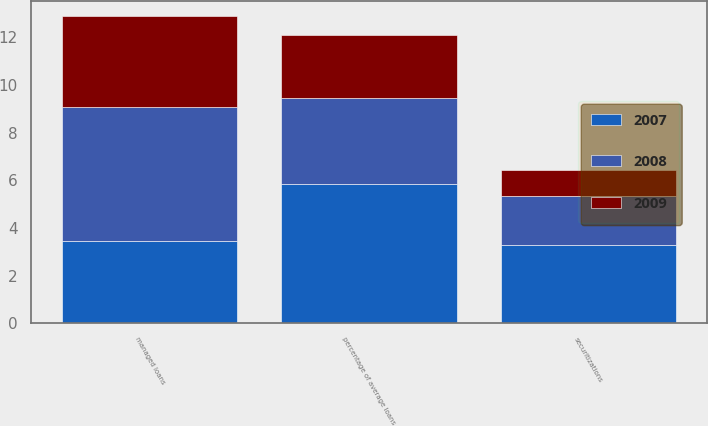<chart> <loc_0><loc_0><loc_500><loc_500><stacked_bar_chart><ecel><fcel>managed loans<fcel>securitizations<fcel>percentage of average loans<nl><fcel>2007<fcel>3.45<fcel>3.3<fcel>5.84<nl><fcel>2008<fcel>5.62<fcel>2.02<fcel>3.6<nl><fcel>2009<fcel>3.81<fcel>1.13<fcel>2.68<nl></chart> 